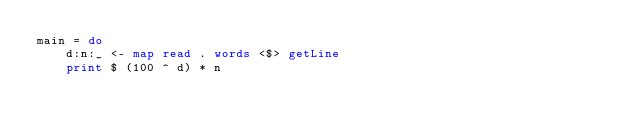<code> <loc_0><loc_0><loc_500><loc_500><_Haskell_>main = do
    d:n:_ <- map read . words <$> getLine
    print $ (100 ^ d) * n</code> 